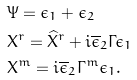Convert formula to latex. <formula><loc_0><loc_0><loc_500><loc_500>& \Psi = \epsilon _ { 1 } + \epsilon _ { 2 } \\ & X ^ { r } = \widehat { X } ^ { r } + i \overline { \epsilon } _ { 2 } \Gamma \epsilon _ { 1 } \\ & X ^ { m } = i \overline { \epsilon } _ { 2 } \Gamma ^ { m } \epsilon _ { 1 } .</formula> 